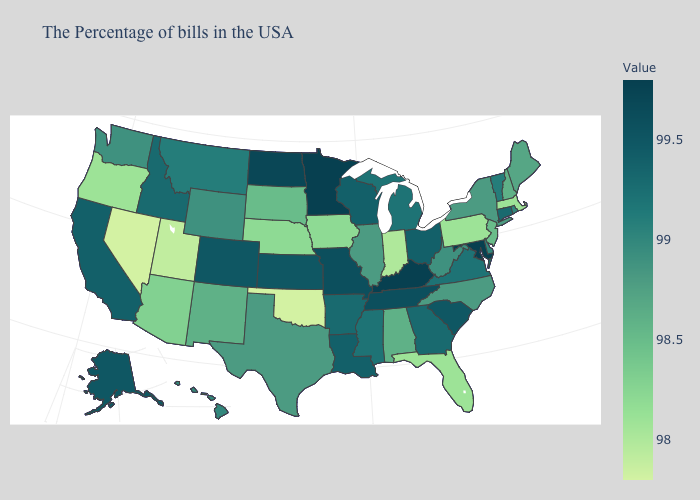Does Kentucky have the highest value in the USA?
Quick response, please. Yes. Does Tennessee have the lowest value in the USA?
Quick response, please. No. Which states have the lowest value in the USA?
Short answer required. Oklahoma, Nevada. Does Hawaii have a lower value than Nevada?
Concise answer only. No. Does Oklahoma have the lowest value in the South?
Quick response, please. Yes. Does Alabama have a lower value than California?
Give a very brief answer. Yes. 